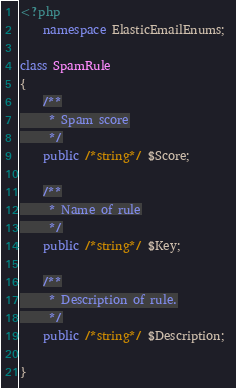<code> <loc_0><loc_0><loc_500><loc_500><_PHP_><?php
	namespace ElasticEmailEnums; 

class SpamRule
{
    /**
     * Spam score
     */
    public /*string*/ $Score;

    /**
     * Name of rule
     */
    public /*string*/ $Key;

    /**
     * Description of rule.
     */
    public /*string*/ $Description;

}
</code> 